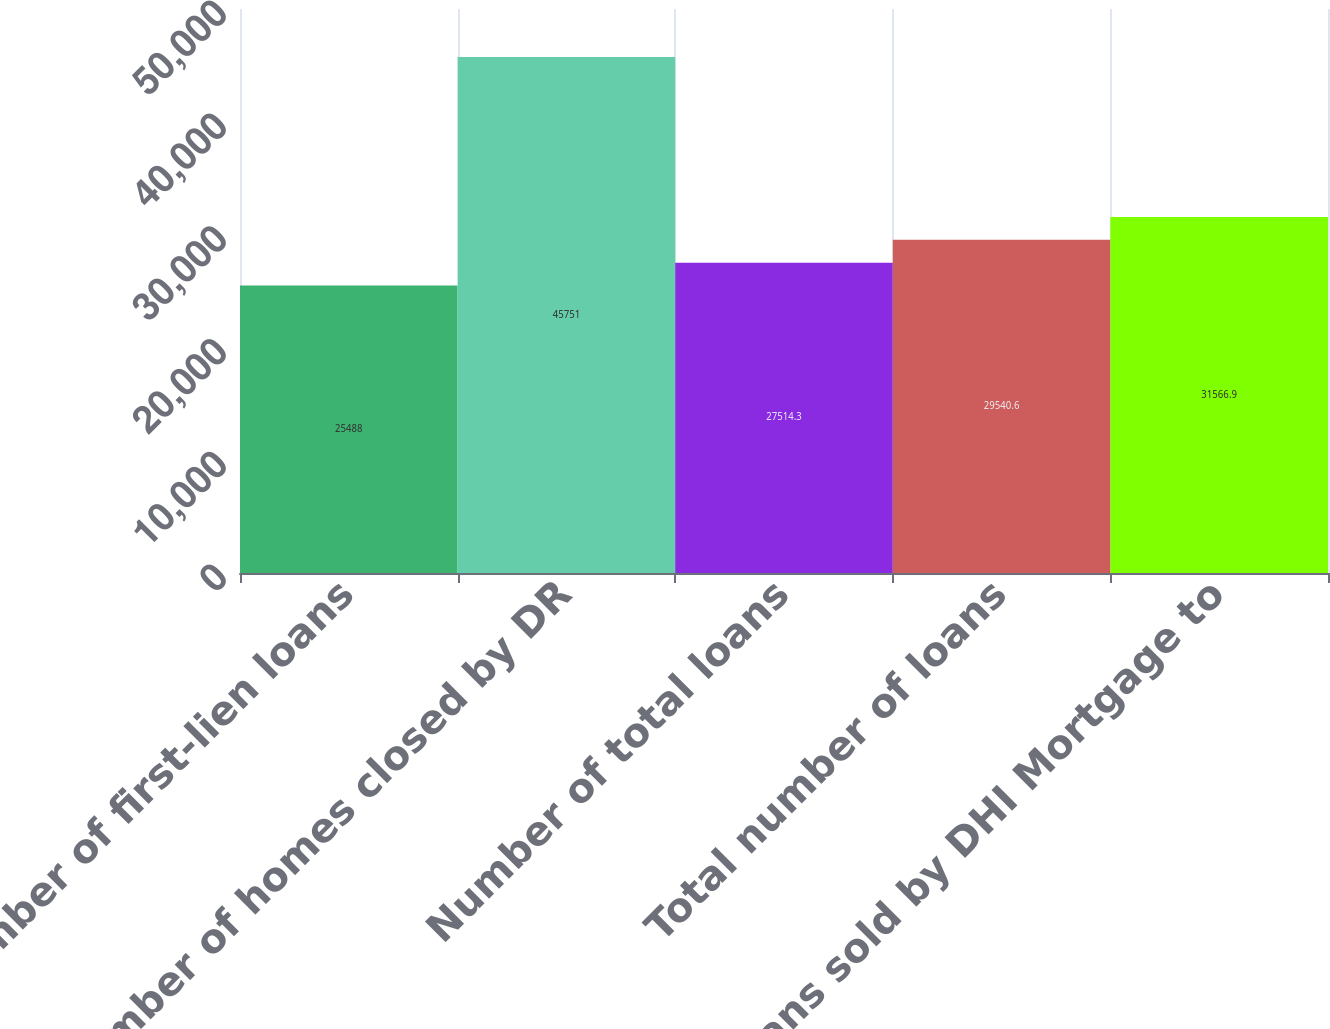Convert chart to OTSL. <chart><loc_0><loc_0><loc_500><loc_500><bar_chart><fcel>Number of first-lien loans<fcel>Number of homes closed by DR<fcel>Number of total loans<fcel>Total number of loans<fcel>Loans sold by DHI Mortgage to<nl><fcel>25488<fcel>45751<fcel>27514.3<fcel>29540.6<fcel>31566.9<nl></chart> 